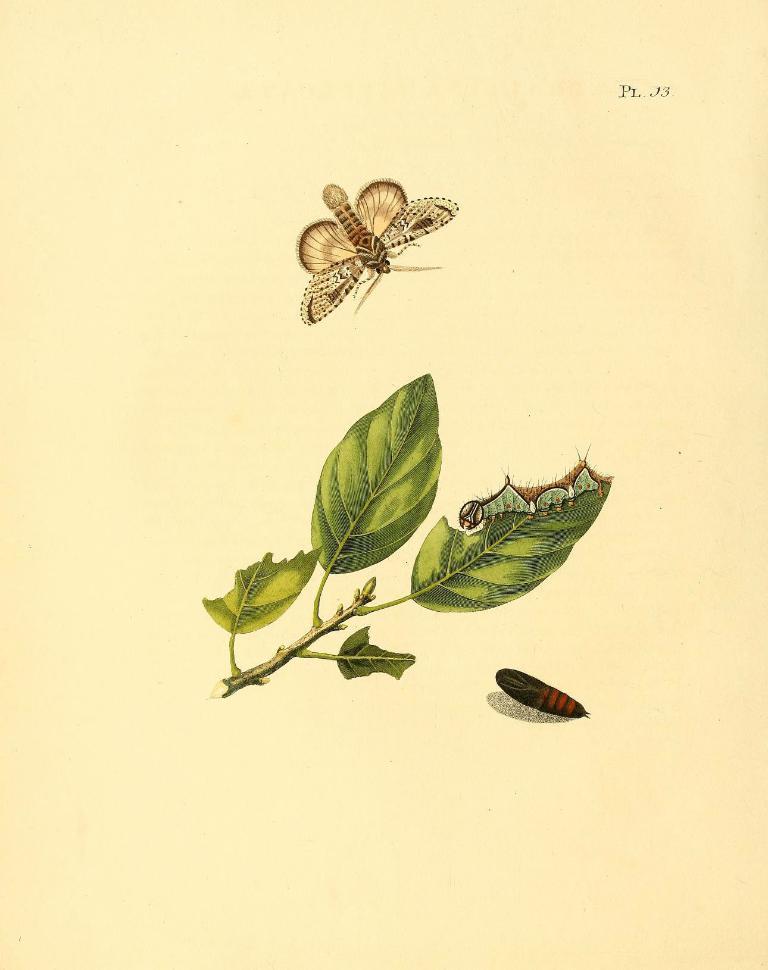Please provide a concise description of this image. In this image I can see depiction picture where I can see green colour leaves and few insects. I can also see cream colour in the background and here I can see something is written. 